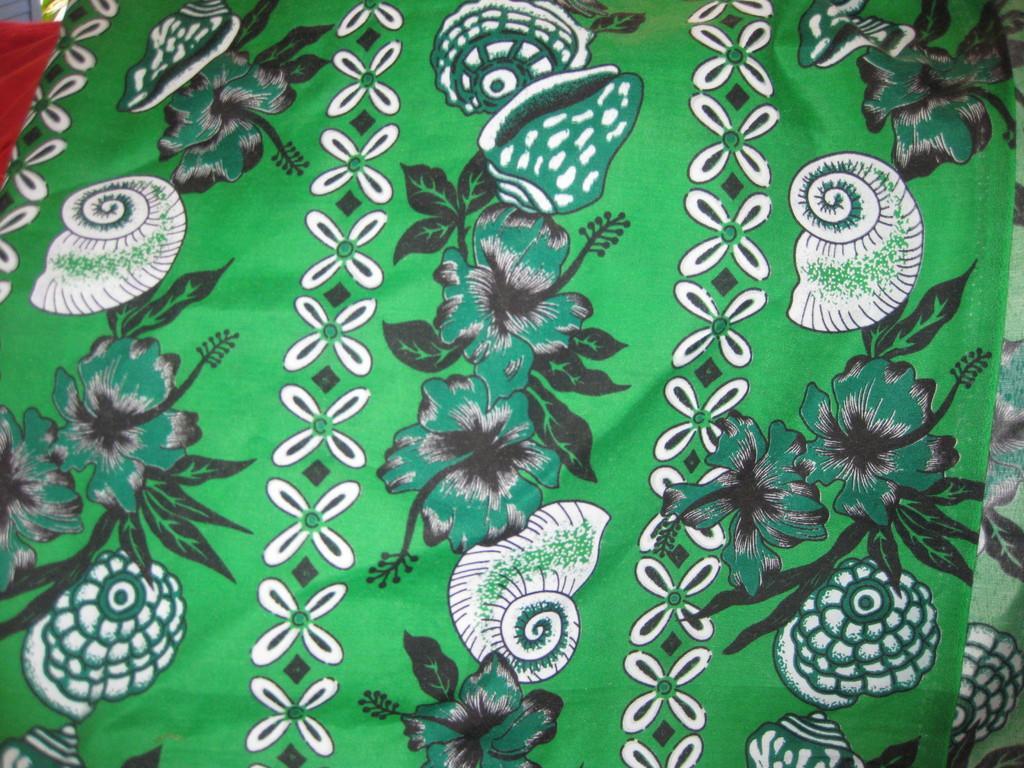In one or two sentences, can you explain what this image depicts? In this image I can see the clothes which are in green, white, black and red color. 